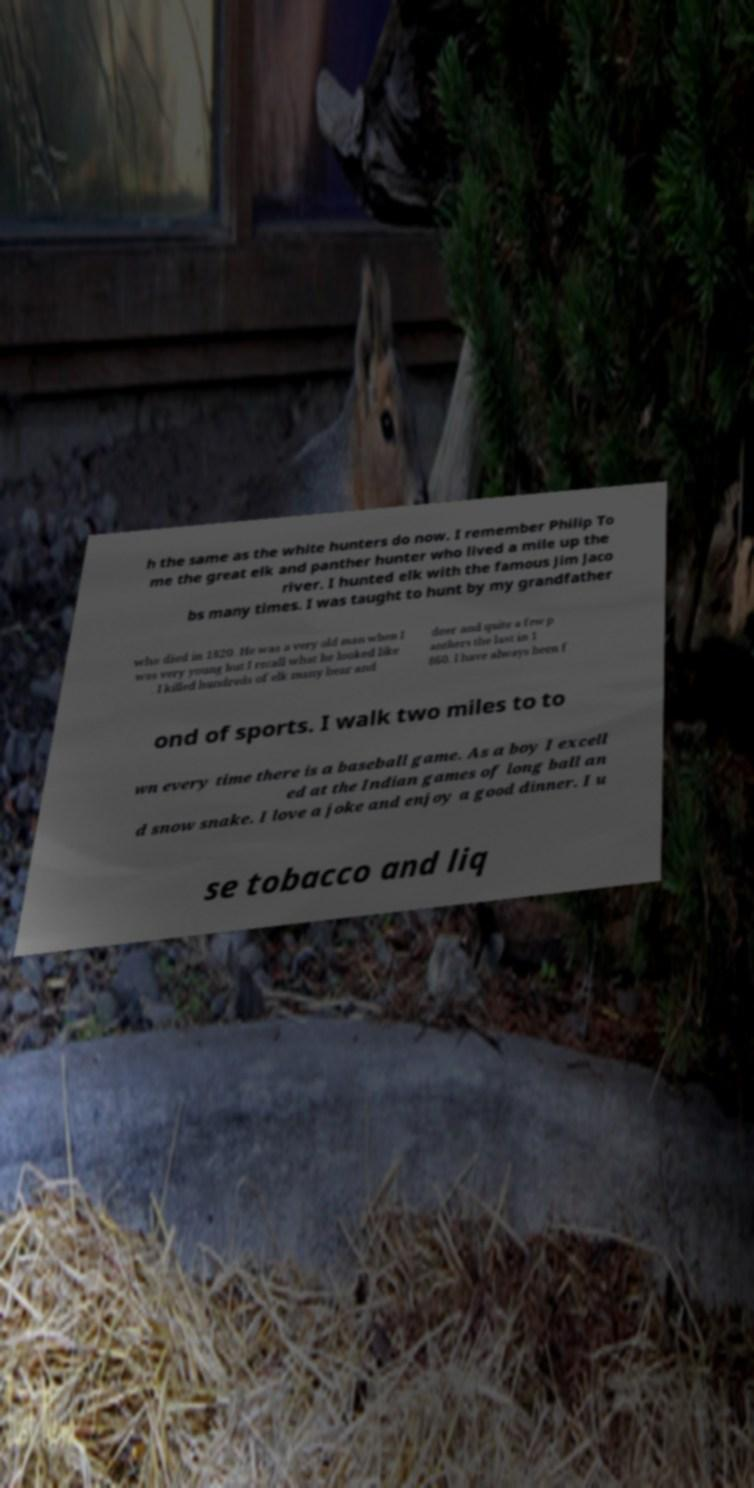Could you assist in decoding the text presented in this image and type it out clearly? h the same as the white hunters do now. I remember Philip To me the great elk and panther hunter who lived a mile up the river. I hunted elk with the famous Jim Jaco bs many times. I was taught to hunt by my grandfather who died in 1820. He was a very old man when I was very young but I recall what he looked like . I killed hundreds of elk many bear and deer and quite a few p anthers the last in 1 860. I have always been f ond of sports. I walk two miles to to wn every time there is a baseball game. As a boy I excell ed at the Indian games of long ball an d snow snake. I love a joke and enjoy a good dinner. I u se tobacco and liq 